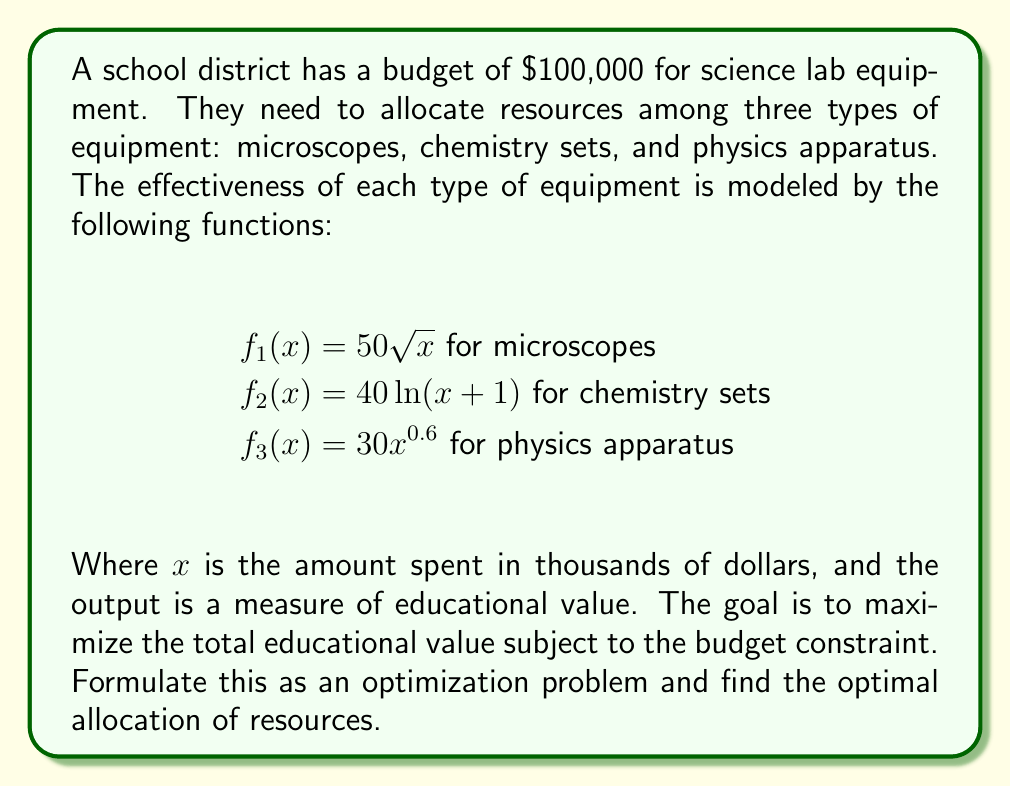What is the answer to this math problem? To solve this problem, we need to use the method of Lagrange multipliers, as we're dealing with a constrained optimization problem.

1. Let $x_1$, $x_2$, and $x_3$ represent the amount spent (in thousands) on microscopes, chemistry sets, and physics apparatus respectively.

2. Our objective function to maximize is:
   $$F(x_1, x_2, x_3) = 50\sqrt{x_1} + 40\ln(x_2+1) + 30x_3^{0.6}$$

3. The constraint is:
   $$g(x_1, x_2, x_3) = x_1 + x_2 + x_3 - 100 = 0$$

4. We form the Lagrangian:
   $$L(x_1, x_2, x_3, \lambda) = 50\sqrt{x_1} + 40\ln(x_2+1) + 30x_3^{0.6} - \lambda(x_1 + x_2 + x_3 - 100)$$

5. Now, we set the partial derivatives equal to zero:

   $$\frac{\partial L}{\partial x_1} = \frac{25}{\sqrt{x_1}} - \lambda = 0$$
   $$\frac{\partial L}{\partial x_2} = \frac{40}{x_2+1} - \lambda = 0$$
   $$\frac{\partial L}{\partial x_3} = 18x_3^{-0.4} - \lambda = 0$$
   $$\frac{\partial L}{\partial \lambda} = x_1 + x_2 + x_3 - 100 = 0$$

6. From these equations, we can derive:

   $$x_1 = \frac{625}{\lambda^2}$$
   $$x_2 = \frac{40}{\lambda} - 1$$
   $$x_3 = (\frac{18}{\lambda})^{2.5}$$

7. Substituting these into the constraint equation:

   $$\frac{625}{\lambda^2} + \frac{40}{\lambda} - 1 + (\frac{18}{\lambda})^{2.5} = 100$$

8. This equation can be solved numerically to find $\lambda \approx 2.5$.

9. Substituting this value back into the expressions for $x_1$, $x_2$, and $x_3$:

   $$x_1 \approx 100$$
   $$x_2 \approx 15$$
   $$x_3 \approx 35$$

Therefore, the optimal allocation is approximately $50,000 for microscopes, $15,000 for chemistry sets, and $35,000 for physics apparatus.
Answer: The optimal allocation of the $100,000 budget is approximately:
$50,000 for microscopes
$15,000 for chemistry sets
$35,000 for physics apparatus 